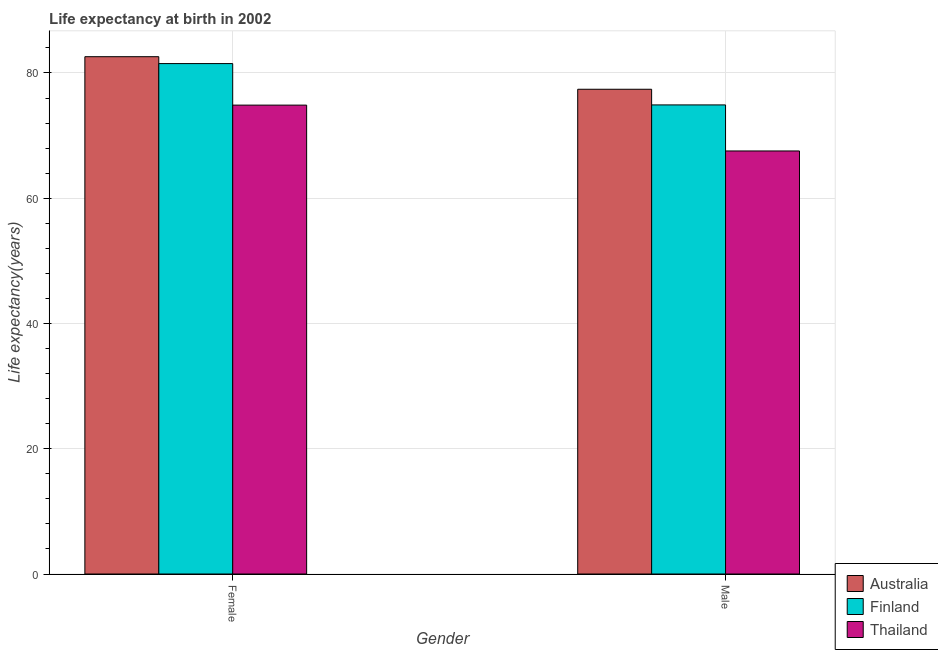Are the number of bars per tick equal to the number of legend labels?
Provide a succinct answer. Yes. Are the number of bars on each tick of the X-axis equal?
Your answer should be compact. Yes. How many bars are there on the 1st tick from the left?
Your response must be concise. 3. How many bars are there on the 1st tick from the right?
Provide a succinct answer. 3. What is the life expectancy(male) in Thailand?
Provide a succinct answer. 67.55. Across all countries, what is the maximum life expectancy(female)?
Offer a very short reply. 82.6. Across all countries, what is the minimum life expectancy(female)?
Ensure brevity in your answer.  74.87. In which country was the life expectancy(female) maximum?
Provide a short and direct response. Australia. In which country was the life expectancy(male) minimum?
Keep it short and to the point. Thailand. What is the total life expectancy(female) in the graph?
Provide a succinct answer. 238.97. What is the difference between the life expectancy(male) in Finland and that in Thailand?
Ensure brevity in your answer.  7.35. What is the difference between the life expectancy(female) in Thailand and the life expectancy(male) in Australia?
Provide a short and direct response. -2.53. What is the average life expectancy(female) per country?
Offer a terse response. 79.66. What is the difference between the life expectancy(female) and life expectancy(male) in Australia?
Make the answer very short. 5.2. In how many countries, is the life expectancy(male) greater than 44 years?
Offer a terse response. 3. What is the ratio of the life expectancy(female) in Australia to that in Thailand?
Provide a short and direct response. 1.1. In how many countries, is the life expectancy(male) greater than the average life expectancy(male) taken over all countries?
Your answer should be very brief. 2. What does the 1st bar from the left in Female represents?
Your answer should be compact. Australia. How many bars are there?
Your response must be concise. 6. Are all the bars in the graph horizontal?
Provide a succinct answer. No. What is the difference between two consecutive major ticks on the Y-axis?
Keep it short and to the point. 20. Are the values on the major ticks of Y-axis written in scientific E-notation?
Keep it short and to the point. No. Does the graph contain any zero values?
Give a very brief answer. No. Does the graph contain grids?
Ensure brevity in your answer.  Yes. Where does the legend appear in the graph?
Provide a short and direct response. Bottom right. How many legend labels are there?
Give a very brief answer. 3. What is the title of the graph?
Offer a very short reply. Life expectancy at birth in 2002. Does "Barbados" appear as one of the legend labels in the graph?
Your answer should be compact. No. What is the label or title of the X-axis?
Provide a short and direct response. Gender. What is the label or title of the Y-axis?
Your response must be concise. Life expectancy(years). What is the Life expectancy(years) in Australia in Female?
Ensure brevity in your answer.  82.6. What is the Life expectancy(years) in Finland in Female?
Ensure brevity in your answer.  81.5. What is the Life expectancy(years) of Thailand in Female?
Your answer should be very brief. 74.87. What is the Life expectancy(years) in Australia in Male?
Your answer should be compact. 77.4. What is the Life expectancy(years) in Finland in Male?
Ensure brevity in your answer.  74.9. What is the Life expectancy(years) in Thailand in Male?
Ensure brevity in your answer.  67.55. Across all Gender, what is the maximum Life expectancy(years) in Australia?
Make the answer very short. 82.6. Across all Gender, what is the maximum Life expectancy(years) of Finland?
Your answer should be very brief. 81.5. Across all Gender, what is the maximum Life expectancy(years) of Thailand?
Make the answer very short. 74.87. Across all Gender, what is the minimum Life expectancy(years) in Australia?
Offer a terse response. 77.4. Across all Gender, what is the minimum Life expectancy(years) in Finland?
Keep it short and to the point. 74.9. Across all Gender, what is the minimum Life expectancy(years) of Thailand?
Offer a very short reply. 67.55. What is the total Life expectancy(years) of Australia in the graph?
Give a very brief answer. 160. What is the total Life expectancy(years) of Finland in the graph?
Your response must be concise. 156.4. What is the total Life expectancy(years) of Thailand in the graph?
Your response must be concise. 142.41. What is the difference between the Life expectancy(years) of Finland in Female and that in Male?
Your answer should be compact. 6.6. What is the difference between the Life expectancy(years) in Thailand in Female and that in Male?
Provide a short and direct response. 7.32. What is the difference between the Life expectancy(years) of Australia in Female and the Life expectancy(years) of Thailand in Male?
Provide a short and direct response. 15.05. What is the difference between the Life expectancy(years) in Finland in Female and the Life expectancy(years) in Thailand in Male?
Offer a very short reply. 13.95. What is the average Life expectancy(years) in Australia per Gender?
Your response must be concise. 80. What is the average Life expectancy(years) in Finland per Gender?
Offer a very short reply. 78.2. What is the average Life expectancy(years) of Thailand per Gender?
Ensure brevity in your answer.  71.21. What is the difference between the Life expectancy(years) of Australia and Life expectancy(years) of Finland in Female?
Give a very brief answer. 1.1. What is the difference between the Life expectancy(years) of Australia and Life expectancy(years) of Thailand in Female?
Provide a succinct answer. 7.73. What is the difference between the Life expectancy(years) in Finland and Life expectancy(years) in Thailand in Female?
Offer a terse response. 6.63. What is the difference between the Life expectancy(years) in Australia and Life expectancy(years) in Finland in Male?
Offer a terse response. 2.5. What is the difference between the Life expectancy(years) of Australia and Life expectancy(years) of Thailand in Male?
Give a very brief answer. 9.85. What is the difference between the Life expectancy(years) of Finland and Life expectancy(years) of Thailand in Male?
Make the answer very short. 7.35. What is the ratio of the Life expectancy(years) in Australia in Female to that in Male?
Give a very brief answer. 1.07. What is the ratio of the Life expectancy(years) of Finland in Female to that in Male?
Provide a succinct answer. 1.09. What is the ratio of the Life expectancy(years) in Thailand in Female to that in Male?
Your response must be concise. 1.11. What is the difference between the highest and the second highest Life expectancy(years) in Finland?
Ensure brevity in your answer.  6.6. What is the difference between the highest and the second highest Life expectancy(years) of Thailand?
Make the answer very short. 7.32. What is the difference between the highest and the lowest Life expectancy(years) in Thailand?
Give a very brief answer. 7.32. 